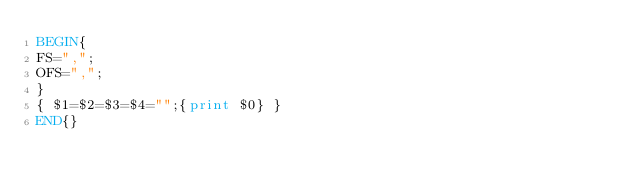<code> <loc_0><loc_0><loc_500><loc_500><_Awk_>BEGIN{
FS=",";
OFS=",";
}
{ $1=$2=$3=$4="";{print $0} }
END{}
</code> 